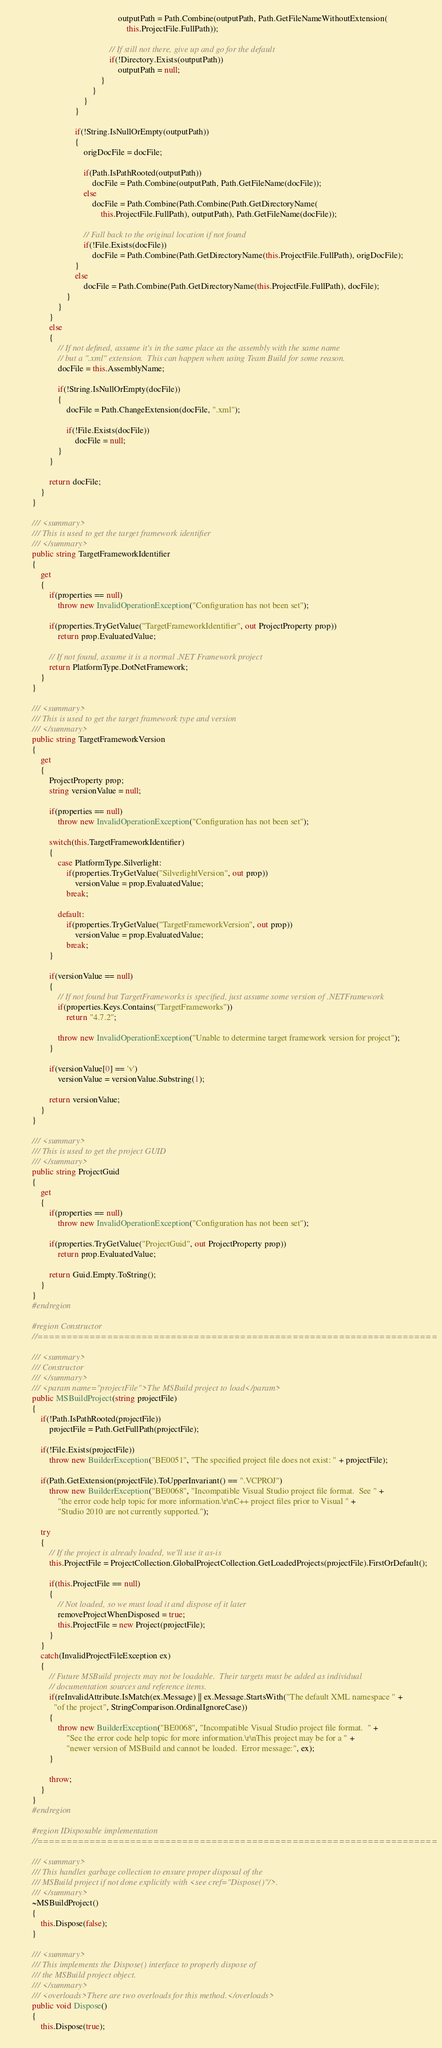<code> <loc_0><loc_0><loc_500><loc_500><_C#_>                                                outputPath = Path.Combine(outputPath, Path.GetFileNameWithoutExtension(
                                                    this.ProjectFile.FullPath));

                                            // If still not there, give up and go for the default
                                            if(!Directory.Exists(outputPath))
                                                outputPath = null;
                                        }
                                    }
                                }
                            }

                            if(!String.IsNullOrEmpty(outputPath))
                            {
                                origDocFile = docFile;

                                if(Path.IsPathRooted(outputPath))
                                    docFile = Path.Combine(outputPath, Path.GetFileName(docFile));
                                else
                                    docFile = Path.Combine(Path.Combine(Path.GetDirectoryName(
                                        this.ProjectFile.FullPath), outputPath), Path.GetFileName(docFile));

                                // Fall back to the original location if not found
                                if(!File.Exists(docFile))
                                    docFile = Path.Combine(Path.GetDirectoryName(this.ProjectFile.FullPath), origDocFile);
                            }
                            else
                                docFile = Path.Combine(Path.GetDirectoryName(this.ProjectFile.FullPath), docFile);
                        }
                    }
                }
                else
                {
                    // If not defined, assume it's in the same place as the assembly with the same name
                    // but a ".xml" extension.  This can happen when using Team Build for some reason.
                    docFile = this.AssemblyName;

                    if(!String.IsNullOrEmpty(docFile))
                    {
                        docFile = Path.ChangeExtension(docFile, ".xml");

                        if(!File.Exists(docFile))
                            docFile = null;
                    }
                }

                return docFile;
            }
        }

        /// <summary>
        /// This is used to get the target framework identifier
        /// </summary>
        public string TargetFrameworkIdentifier
        {
            get
            {
                if(properties == null)
                    throw new InvalidOperationException("Configuration has not been set");

                if(properties.TryGetValue("TargetFrameworkIdentifier", out ProjectProperty prop))
                    return prop.EvaluatedValue;

                // If not found, assume it is a normal .NET Framework project
                return PlatformType.DotNetFramework;
            }
        }

        /// <summary>
        /// This is used to get the target framework type and version
        /// </summary>
        public string TargetFrameworkVersion
        {
            get
            {
                ProjectProperty prop;
                string versionValue = null;

                if(properties == null)
                    throw new InvalidOperationException("Configuration has not been set");

                switch(this.TargetFrameworkIdentifier)
                {
                    case PlatformType.Silverlight:
                        if(properties.TryGetValue("SilverlightVersion", out prop))
                            versionValue = prop.EvaluatedValue;
                        break;

                    default:
                        if(properties.TryGetValue("TargetFrameworkVersion", out prop))
                            versionValue = prop.EvaluatedValue;
                        break;
                }

                if(versionValue == null)
                {
                    // If not found but TargetFrameworks is specified, just assume some version of .NETFramework
                    if(properties.Keys.Contains("TargetFrameworks"))
                        return "4.7.2";

                    throw new InvalidOperationException("Unable to determine target framework version for project");
                }

                if(versionValue[0] == 'v')
                    versionValue = versionValue.Substring(1);

                return versionValue;
            }
        }

        /// <summary>
        /// This is used to get the project GUID
        /// </summary>
        public string ProjectGuid
        {
            get
            {
                if(properties == null)
                    throw new InvalidOperationException("Configuration has not been set");

                if(properties.TryGetValue("ProjectGuid", out ProjectProperty prop))
                    return prop.EvaluatedValue;

                return Guid.Empty.ToString();
            }
        }
        #endregion

        #region Constructor
        //=====================================================================

        /// <summary>
        /// Constructor
        /// </summary>
        /// <param name="projectFile">The MSBuild project to load</param>
        public MSBuildProject(string projectFile)
        {
            if(!Path.IsPathRooted(projectFile))
                projectFile = Path.GetFullPath(projectFile);

            if(!File.Exists(projectFile))
                throw new BuilderException("BE0051", "The specified project file does not exist: " + projectFile);

            if(Path.GetExtension(projectFile).ToUpperInvariant() == ".VCPROJ")
                throw new BuilderException("BE0068", "Incompatible Visual Studio project file format.  See " +
                    "the error code help topic for more information.\r\nC++ project files prior to Visual " +
                    "Studio 2010 are not currently supported.");

            try
            {
                // If the project is already loaded, we'll use it as-is
                this.ProjectFile = ProjectCollection.GlobalProjectCollection.GetLoadedProjects(projectFile).FirstOrDefault();

                if(this.ProjectFile == null)
                {
                    // Not loaded, so we must load it and dispose of it later
                    removeProjectWhenDisposed = true;
                    this.ProjectFile = new Project(projectFile);
                }
            }
            catch(InvalidProjectFileException ex)
            {
                // Future MSBuild projects may not be loadable.  Their targets must be added as individual
                // documentation sources and reference items.
                if(reInvalidAttribute.IsMatch(ex.Message) || ex.Message.StartsWith("The default XML namespace " +
                  "of the project", StringComparison.OrdinalIgnoreCase))
                {
                    throw new BuilderException("BE0068", "Incompatible Visual Studio project file format.  " +
                        "See the error code help topic for more information.\r\nThis project may be for a " +
                        "newer version of MSBuild and cannot be loaded.  Error message:", ex);
                }

                throw;
            }
        }
        #endregion

        #region IDisposable implementation
        //=====================================================================

        /// <summary>
        /// This handles garbage collection to ensure proper disposal of the
        /// MSBuild project if not done explicitly with <see cref="Dispose()"/>.
        /// </summary>
        ~MSBuildProject()
        {
            this.Dispose(false);
        }

        /// <summary>
        /// This implements the Dispose() interface to properly dispose of
        /// the MSBuild project object.
        /// </summary>
        /// <overloads>There are two overloads for this method.</overloads>
        public void Dispose()
        {
            this.Dispose(true);</code> 